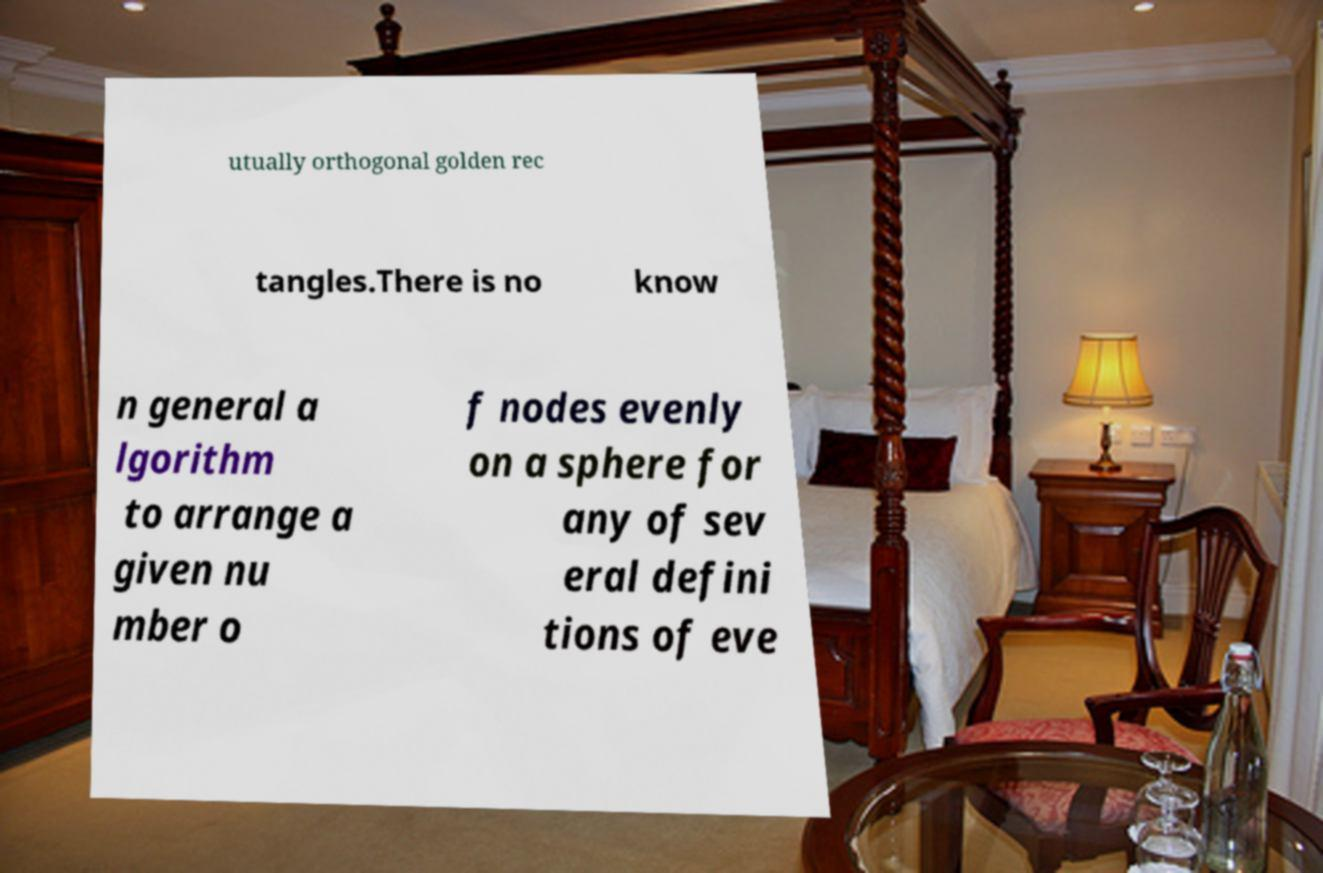Could you assist in decoding the text presented in this image and type it out clearly? utually orthogonal golden rec tangles.There is no know n general a lgorithm to arrange a given nu mber o f nodes evenly on a sphere for any of sev eral defini tions of eve 